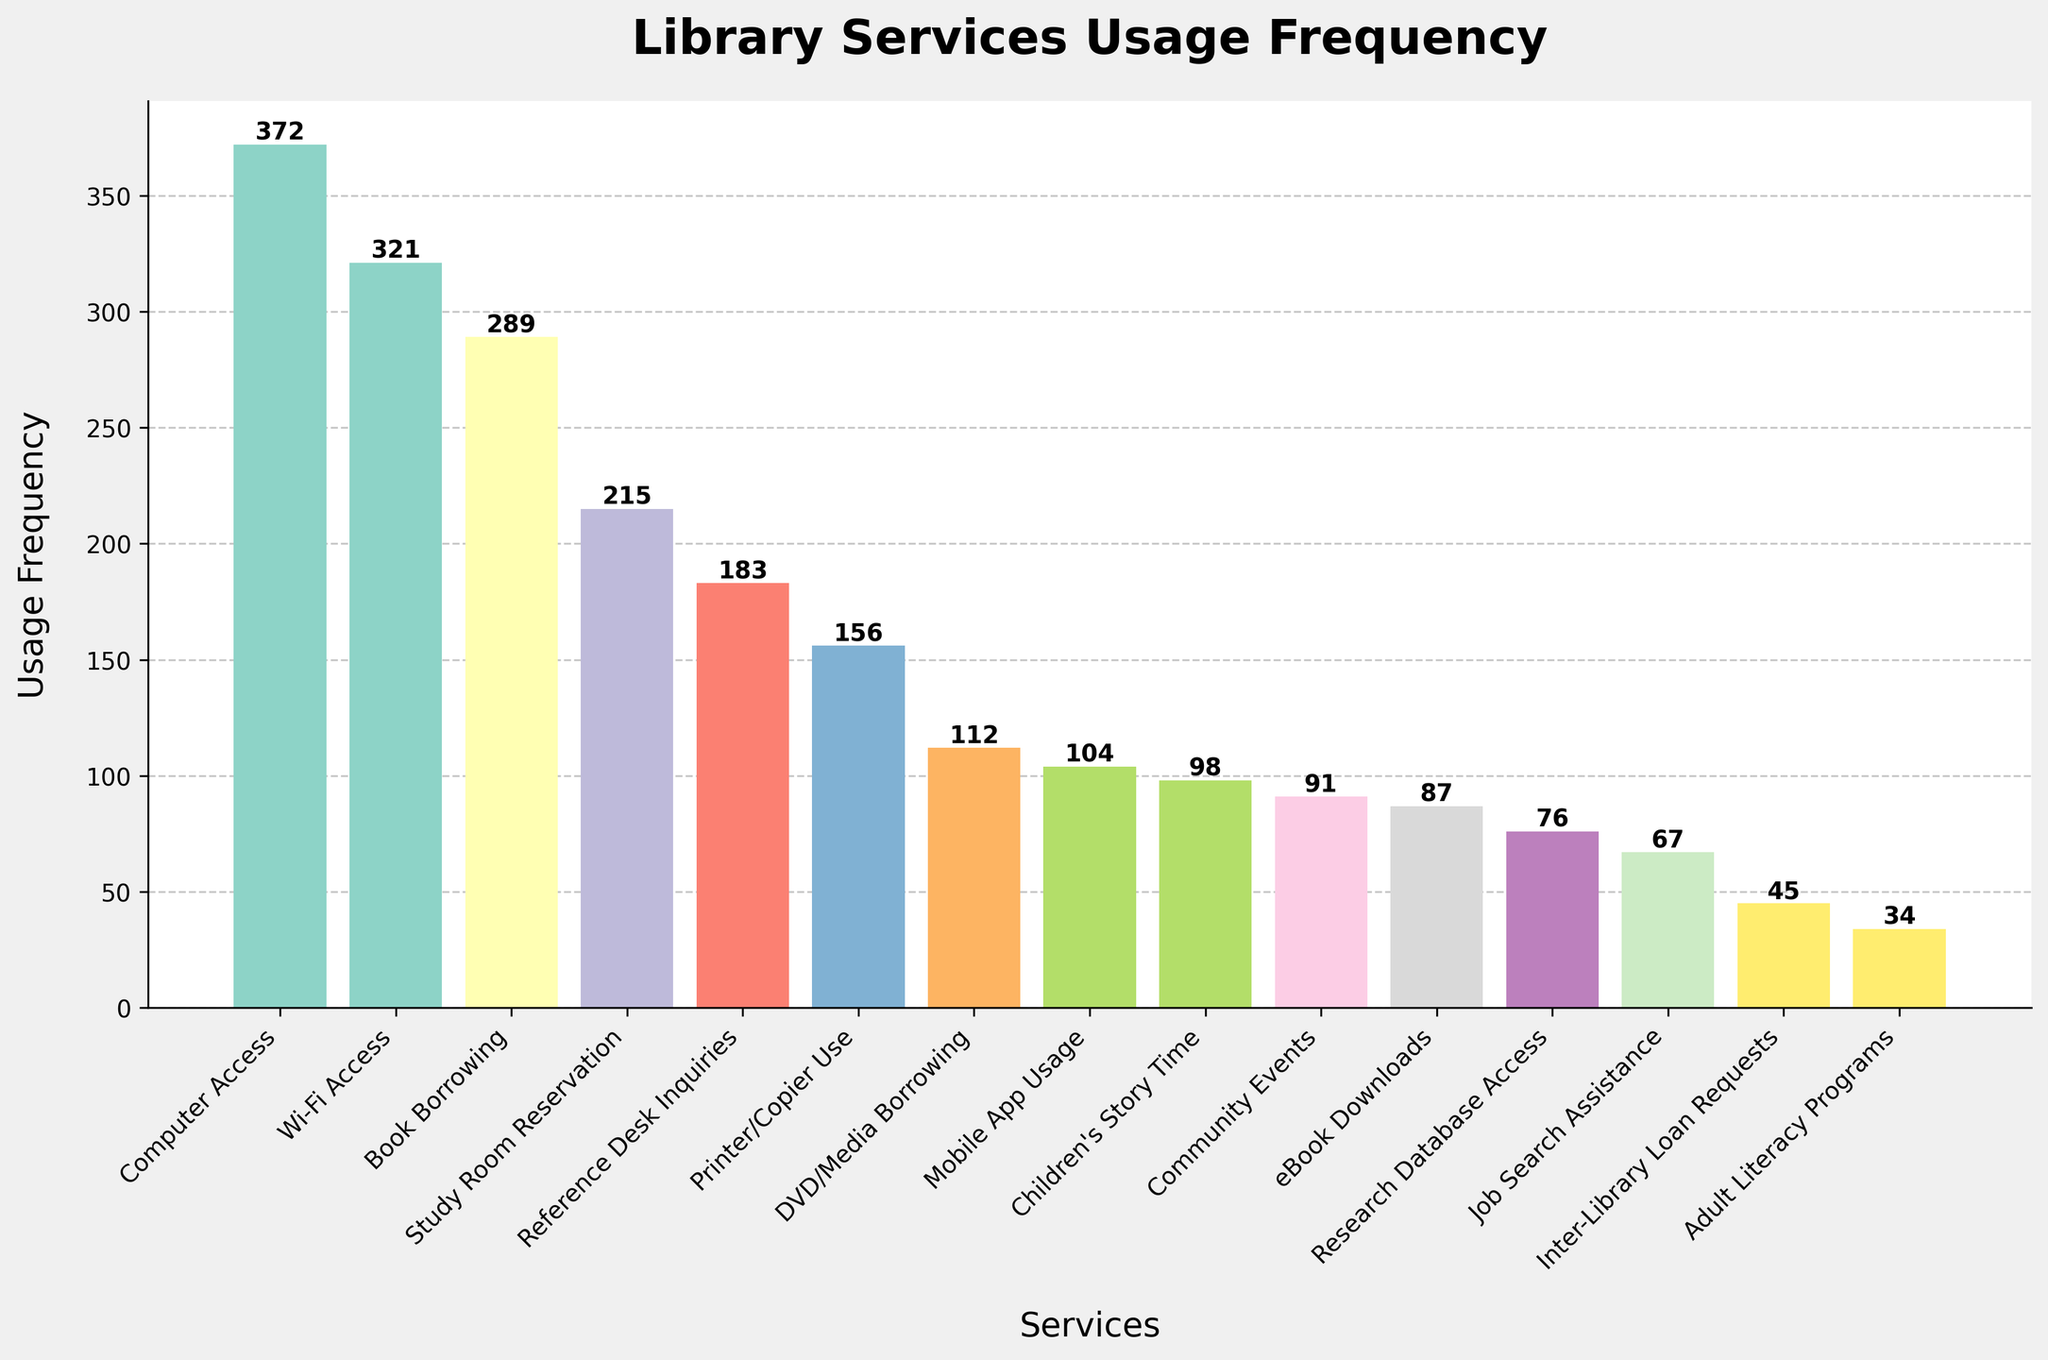Which library service is used the most? To find the most used service, look at the tallest bar on the chart. The tallest bar represents Computer Access with a usage frequency of 372.
Answer: Computer Access Which service is used more frequently, Study Room Reservation or Community Events? Compare the heights of the bars for Study Room Reservation and Community Events. Study Room Reservation has a frequency of 215, while Community Events has 91.
Answer: Study Room Reservation What is the total usage frequency of Wi-Fi Access, Computer Access, and eBook Downloads combined? Sum the usage frequencies of Wi-Fi Access (321), Computer Access (372), and eBook Downloads (87). The total is 321 + 372 + 87 = 780.
Answer: 780 Which service has the lowest usage? Identify the shortest bar on the chart, which represents the data point with the smallest frequency. The shortest bar is for Adult Literacy Programs with a frequency of 34.
Answer: Adult Literacy Programs How much more frequently is Book Borrowing used compared to Reference Desk Inquiries? Subtract the usage frequency of Reference Desk Inquiries (183) from Book Borrowing (289). The difference is 289 - 183 = 106.
Answer: 106 What is the average usage frequency of Printer/Copier Use, DVD/Media Borrowing, and Mobile App Usage? Add the usage frequencies for Printer/Copier Use (156), DVD/Media Borrowing (112), and Mobile App Usage (104), then divide by 3. The average is (156 + 112 + 104) / 3 = 124.
Answer: 124 If we remove the usage of Computer Access, what would be the new highest frequency service? With Computer Access removed, the next highest bar is Wi-Fi Access with a frequency of 321.
Answer: Wi-Fi Access Which services have a usage frequency higher than 200? Identify bars with heights above 200. These are Computer Access (372), Wi-Fi Access (321), Book Borrowing (289), and Study Room Reservation (215).
Answer: Computer Access, Wi-Fi Access, Book Borrowing, Study Room Reservation What is the total usage of all services provided by the library? Sum the usage frequencies of all services. The total is 372 + 289 + 215 + 183 + 156 + 98 + 87 + 321 + 112 + 76 + 45 + 34 + 67 + 91 + 104 = 2250.
Answer: 2250 